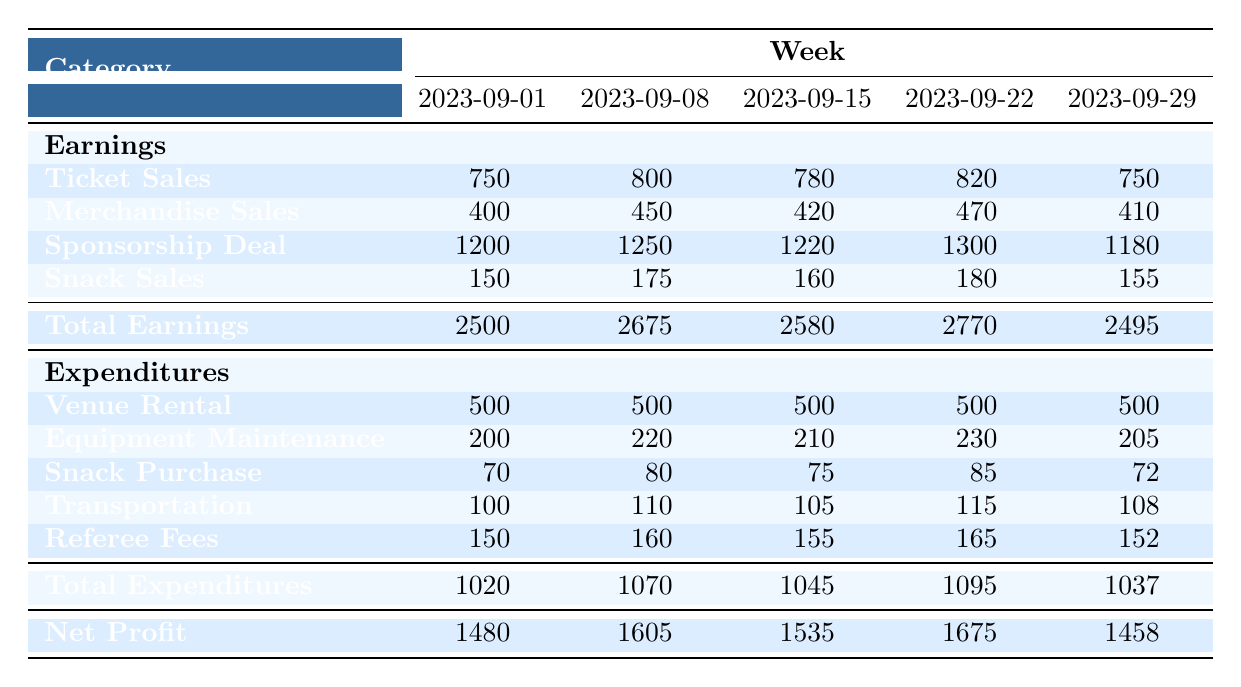What were the total earnings for the week of 2023-09-15? The total earnings for 2023-09-15 are listed in the table under “Total Earnings.” It shows a value of 2580.
Answer: 2580 What was the expenditure on snack purchases for the week of 2023-09-22? The expenditure on snack purchases for 2023-09-22 is provided in the table under “Snack Purchase.” It indicates a value of 85.
Answer: 85 What was the change in net profit from the week of 2023-09-08 to 2023-09-15? The net profit for 2023-09-08 is 1605 and for 2023-09-15 is 1535. The change in net profit is calculated as 1605 - 1535 = 70.
Answer: 70 Was the total expenditure for 2023-09-29 greater than 1040? The total expenditure for 2023-09-29 is listed in the table as 1037, which is less than 1040. Therefore, the answer is no.
Answer: No What is the average sponsorship deal across all weeks? The sponsorship deals for each week are 1200, 1250, 1220, 1300, and 1180. To find the average, sum these values (1200 + 1250 + 1220 + 1300 + 1180 = 6090) and divide by 5, which gives 6090 / 5 = 1218.
Answer: 1218 Which week had the highest earnings and what was the value? To find the week with the highest earnings, we compare the values in the “Total Earnings” row. The highest value is 2770 for the week of 2023-09-22.
Answer: 2023-09-22, 2770 What was the total expenditure in the week of 2023-09-08? The total expenditure for the week of 2023-09-08 is provided in the table under “Total Expenditures.” It shows a value of 1070.
Answer: 1070 How much more did ticket sales generate in revenue in the week of 2023-09-01 compared to the week of 2023-09-29? Ticket sales for 2023-09-01 amount to 750 while for 2023-09-29, it is 750 as well. Therefore, the revenue generated from ticket sales in both weeks is the same, resulting in a difference of 0.
Answer: 0 